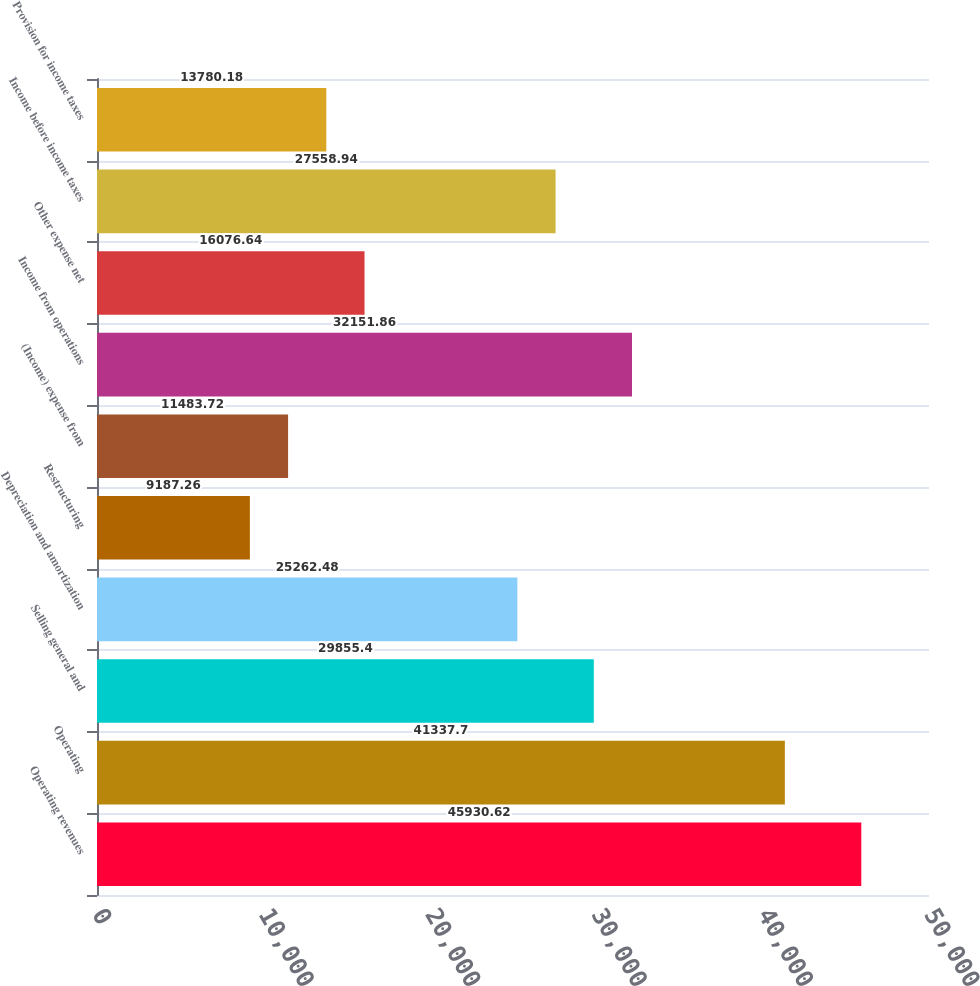<chart> <loc_0><loc_0><loc_500><loc_500><bar_chart><fcel>Operating revenues<fcel>Operating<fcel>Selling general and<fcel>Depreciation and amortization<fcel>Restructuring<fcel>(Income) expense from<fcel>Income from operations<fcel>Other expense net<fcel>Income before income taxes<fcel>Provision for income taxes<nl><fcel>45930.6<fcel>41337.7<fcel>29855.4<fcel>25262.5<fcel>9187.26<fcel>11483.7<fcel>32151.9<fcel>16076.6<fcel>27558.9<fcel>13780.2<nl></chart> 